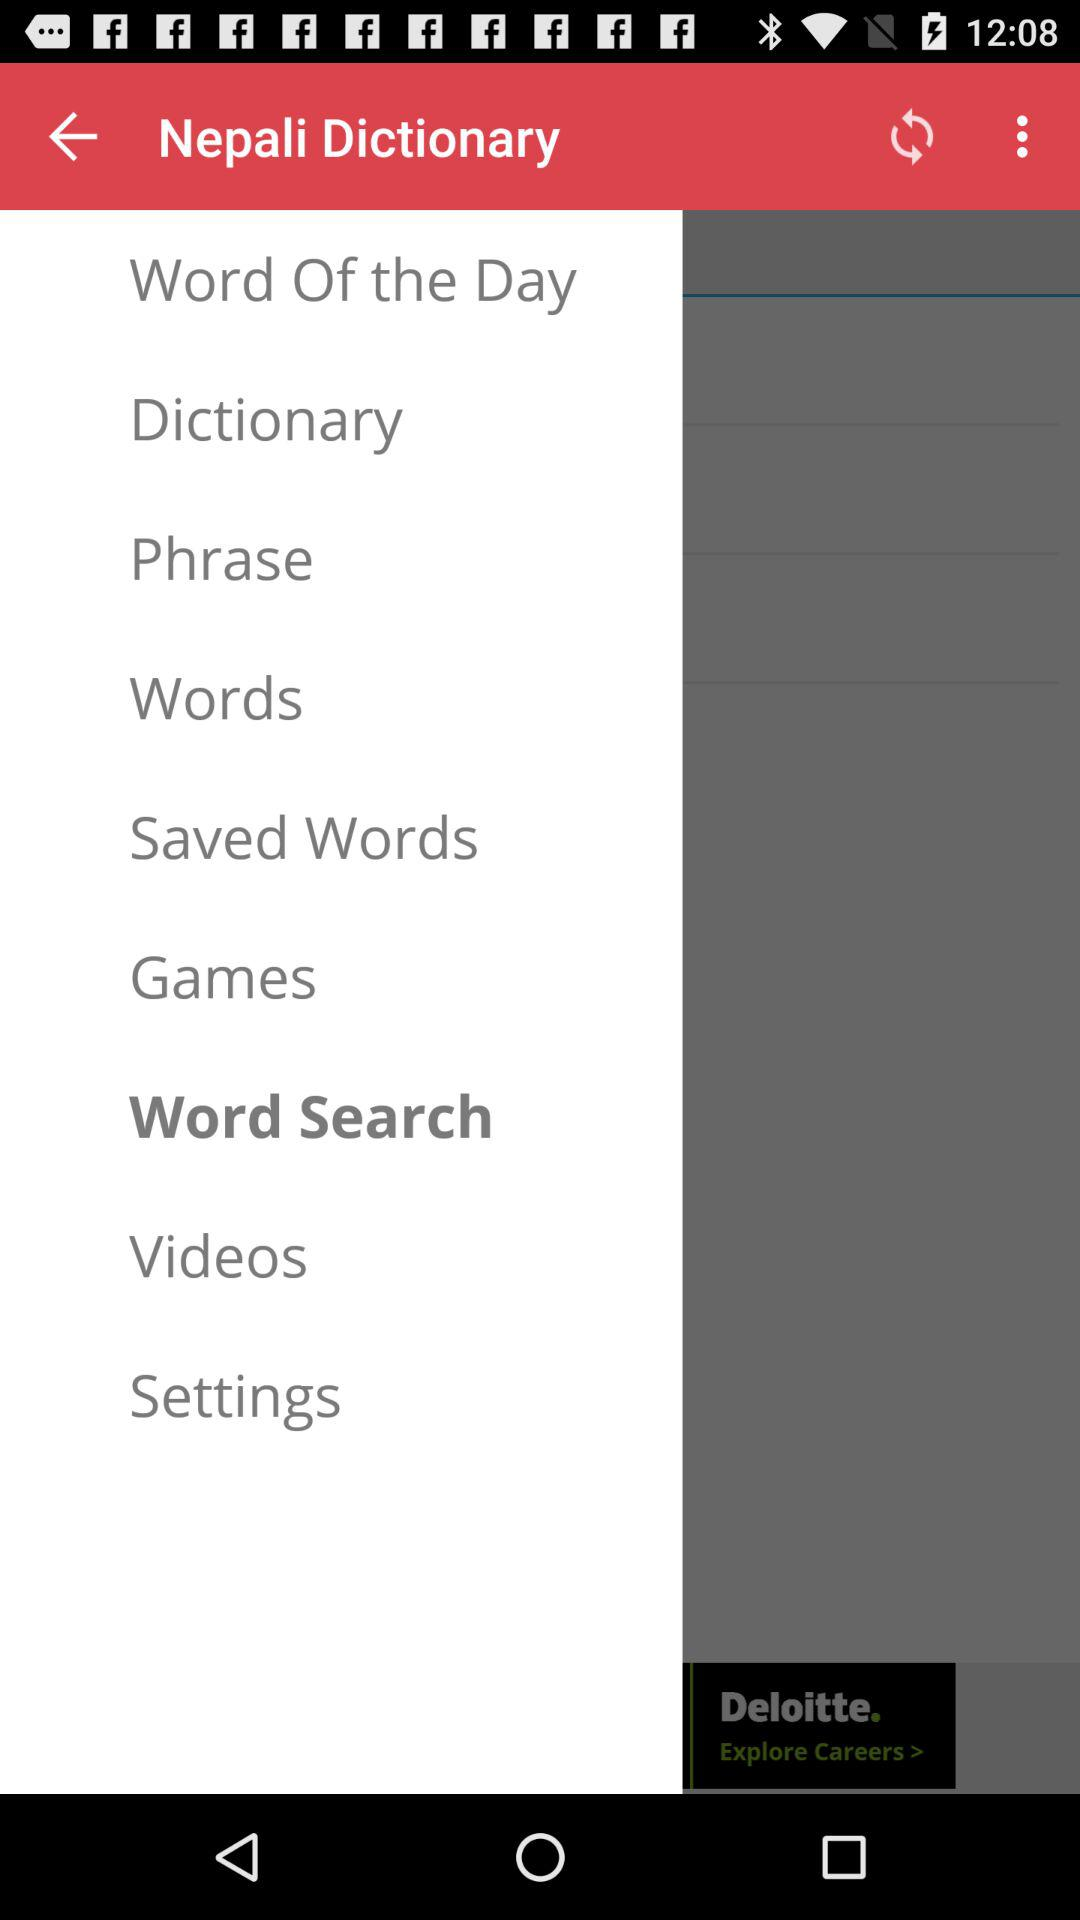How many videos are available?
When the provided information is insufficient, respond with <no answer>. <no answer> 